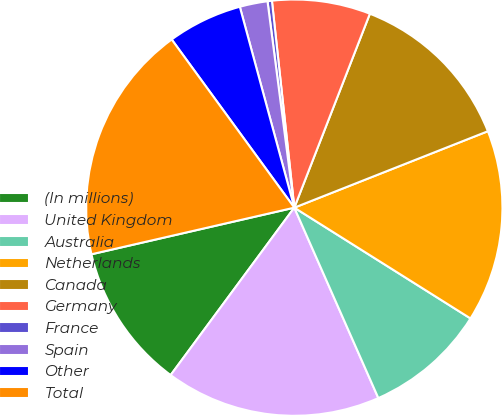<chart> <loc_0><loc_0><loc_500><loc_500><pie_chart><fcel>(In millions)<fcel>United Kingdom<fcel>Australia<fcel>Netherlands<fcel>Canada<fcel>Germany<fcel>France<fcel>Spain<fcel>Other<fcel>Total<nl><fcel>11.28%<fcel>16.74%<fcel>9.45%<fcel>14.92%<fcel>13.1%<fcel>7.63%<fcel>0.34%<fcel>2.16%<fcel>5.81%<fcel>18.57%<nl></chart> 